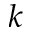Convert formula to latex. <formula><loc_0><loc_0><loc_500><loc_500>k</formula> 